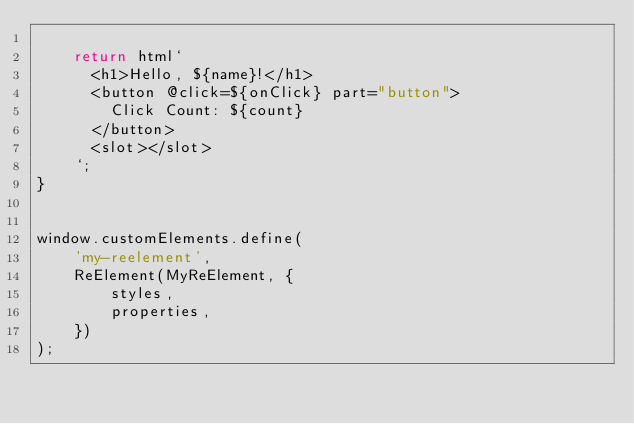<code> <loc_0><loc_0><loc_500><loc_500><_JavaScript_>
    return html`
      <h1>Hello, ${name}!</h1>
      <button @click=${onClick} part="button">
        Click Count: ${count}
      </button>
      <slot></slot>
    `;
}


window.customElements.define(
    'my-reelement',
    ReElement(MyReElement, {
        styles,
        properties,
    })
);</code> 